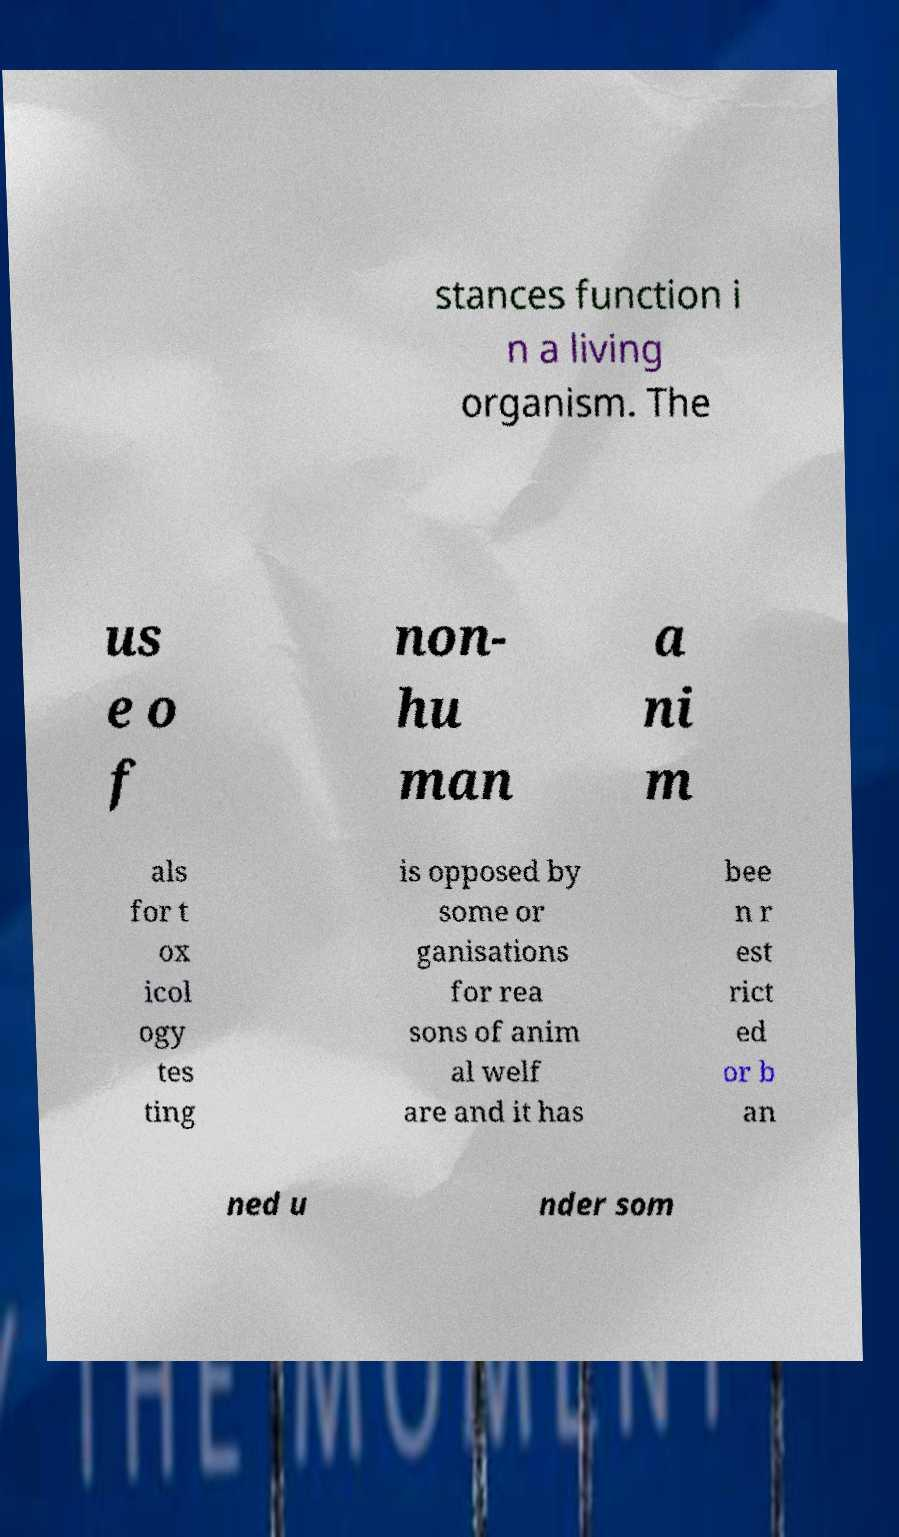I need the written content from this picture converted into text. Can you do that? stances function i n a living organism. The us e o f non- hu man a ni m als for t ox icol ogy tes ting is opposed by some or ganisations for rea sons of anim al welf are and it has bee n r est rict ed or b an ned u nder som 